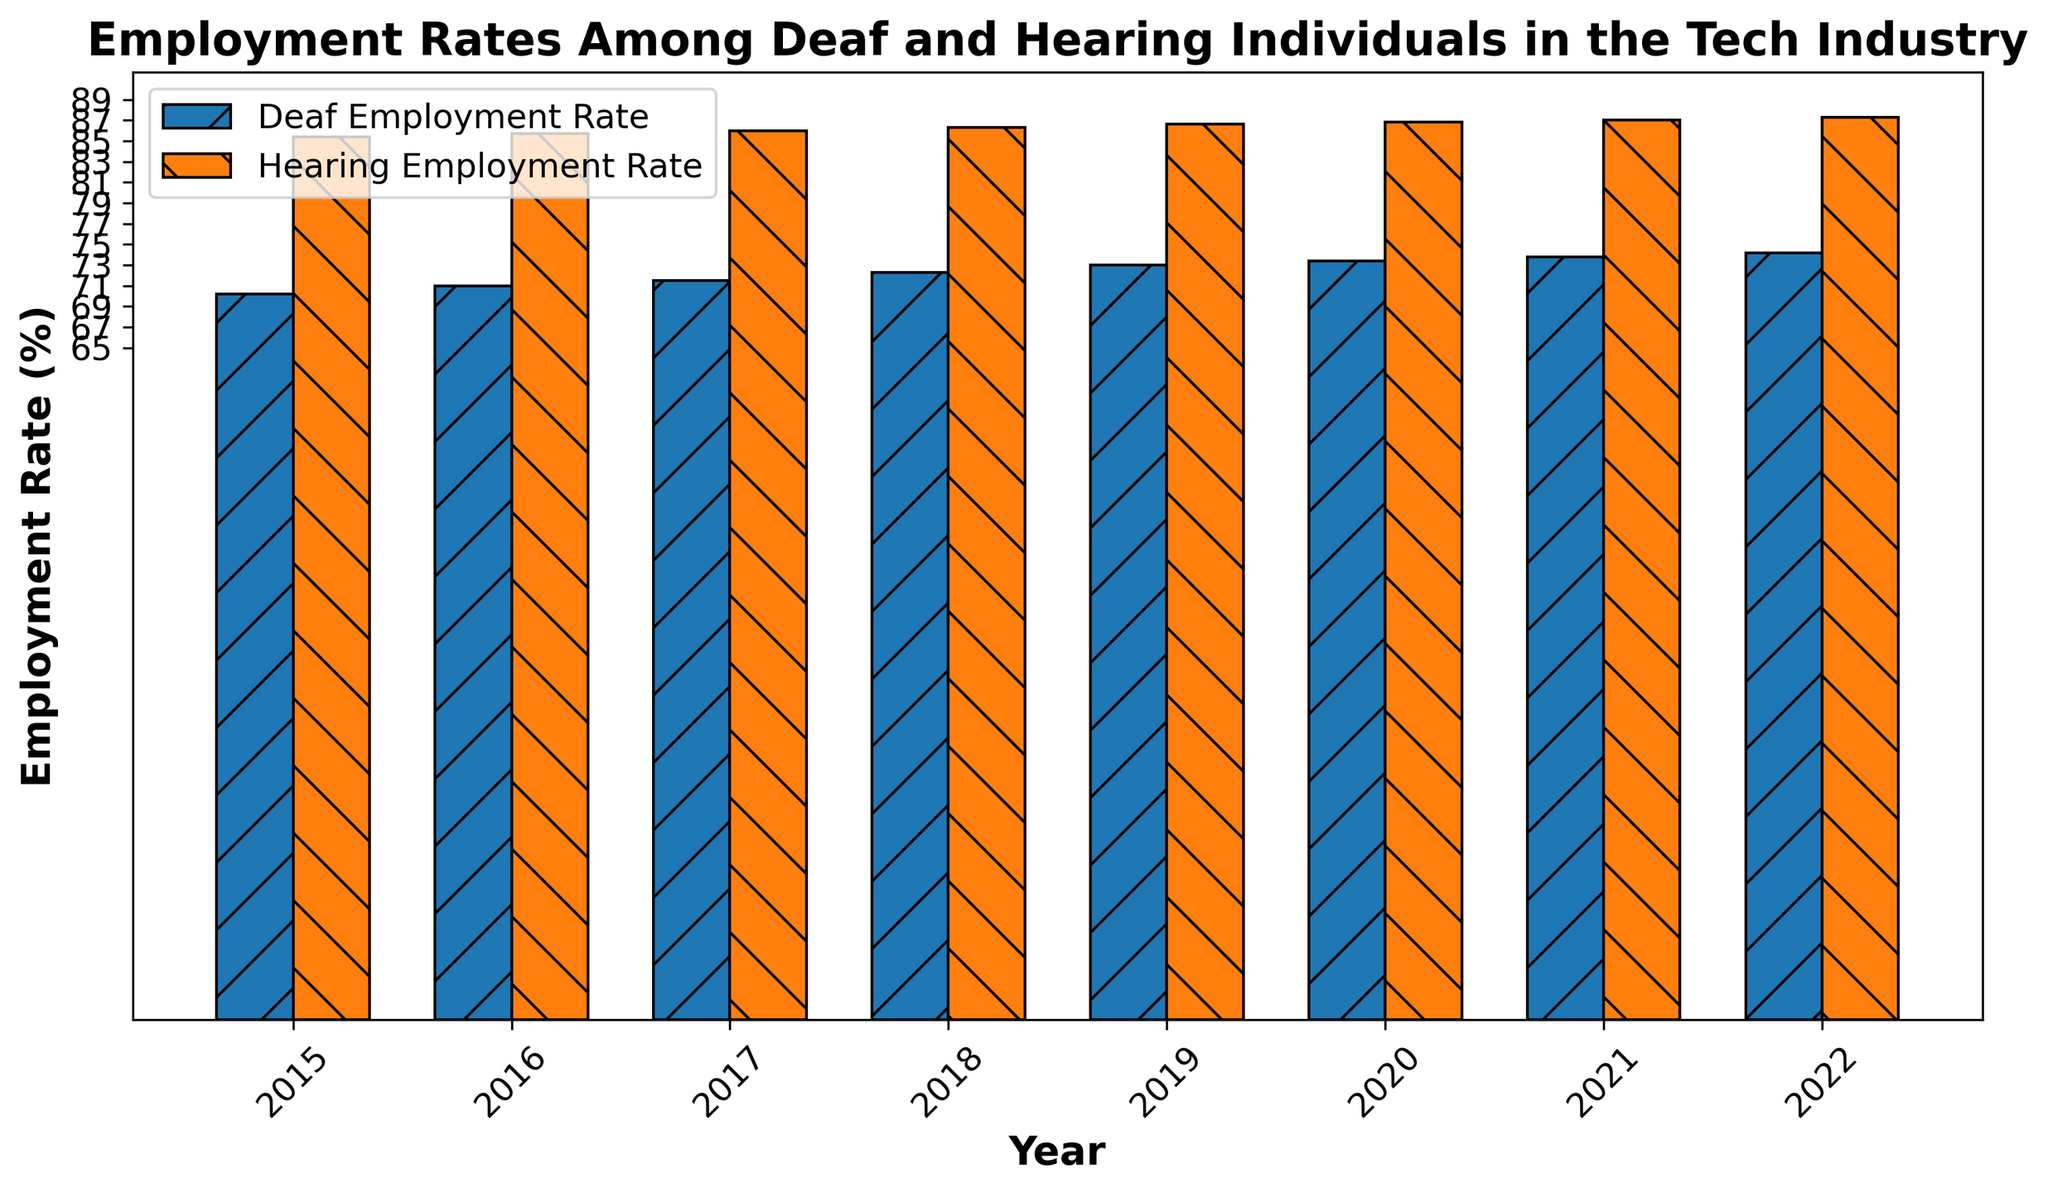what is the hearing employment rate in 2018? The value can be seen directly on the bar labeled 2018 for the Hearing Employment Rate
Answer: 86.3 how does the deaf employment rate in 2020 compare to that in 2015? The deaf employment rate in 2020 is 73.4% and in 2015 it is 70.2%. Comparing these two, 73.4% is greater than 70.2%
Answer: 73.4% > 70.2% what is the difference in employment rates between deaf and hearing individuals in 2022? To calculate the difference, subtract the Deaf Employment Rate from the Hearing Employment Rate for 2022: 87.3% - 74.2% = 13.1%
Answer: 13.1% which year shows the smallest gap between deaf and hearing employment rates? By examining the gaps year by year:
- 2015: 85.4 - 70.2 = 15.2%
- 2016: 85.7 - 71.0 = 14.7%
- 2017: 86.0 - 71.5 = 14.5%
- 2018: 86.3 - 72.3 = 14.0%
- 2019: 86.6 - 73.0 = 13.6%
- 2020: 86.8 - 73.4 = 13.4%
- 2021: 87.0 - 73.8 = 13.2%
- 2022: 87.3 - 74.2 = 13.1%
The smallest gap is in 2022 at 13.1%
Answer: 2022 what is the average employment rate for deaf individuals over the given years? The average can be calculated as: (70.2 + 71.0 + 71.5 + 72.3 + 73.0 + 73.4 + 73.8 + 74.2) / 8 = 572.4 / 8 = 71.55%
Answer: 71.55% which bars are taller, representing higher values, in each year? By observing the heights of bars, the Hearing Employment Rate bars are taller in all years, indicating higher values
Answer: Hearing Employment Rate bars what trend do you observe in the employment rates of deaf individuals from 2015 to 2022? The employment rates for deaf individuals show a gradual increase from 70.2% in 2015 to 74.2% in 2022, indicating an upward trend
Answer: Upward trend in what year did the employment rate for deaf individuals first exceed 73%? According to the data, the deaf employment rate first exceeds 73% in 2019
Answer: 2019 